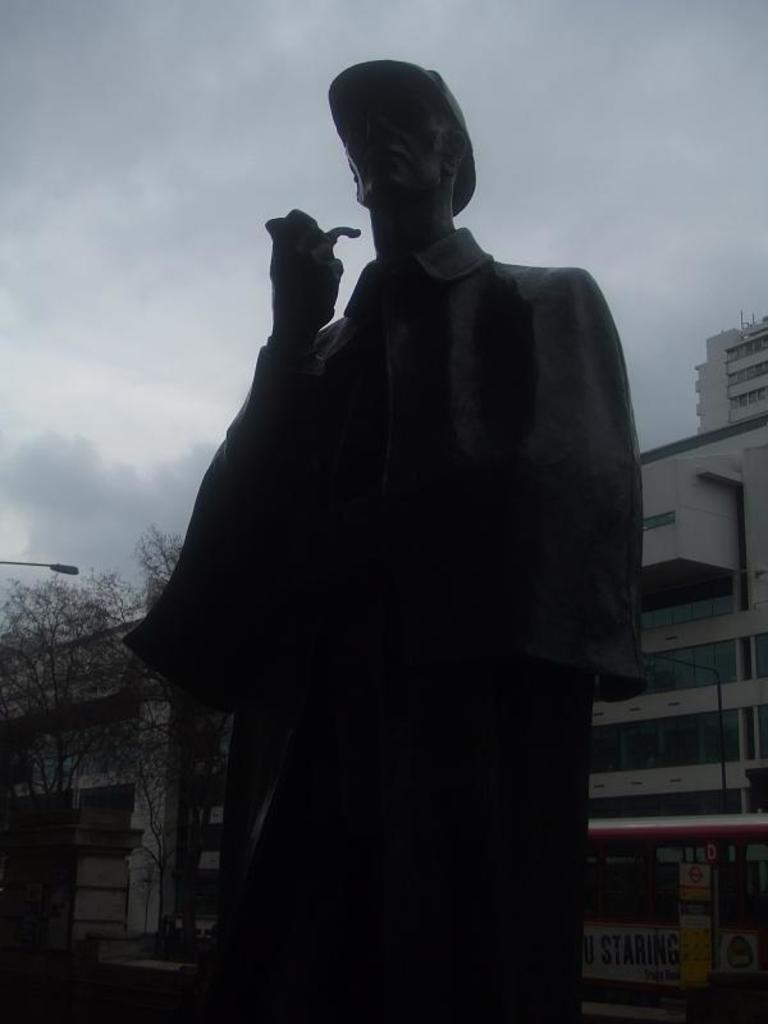Where was the image taken? The image was taken outside. What is in the foreground of the image? There is a sculpture of a person in the foreground. What can be seen in the background of the image? The sky, buildings, trees, and a street light are visible in the background. What type of bells can be heard ringing in the image? There are no bells present in the image, and therefore no sound can be heard. 